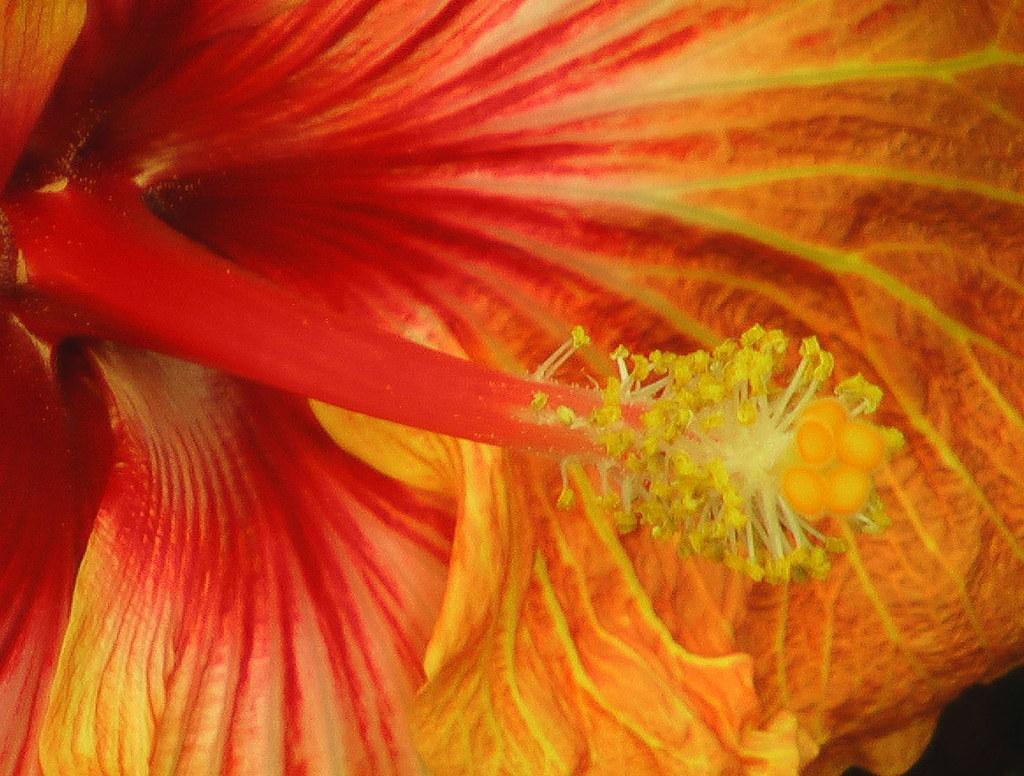Describe this image in one or two sentences. This is the picture of a flower. In this image there is an orange and red color flower. 